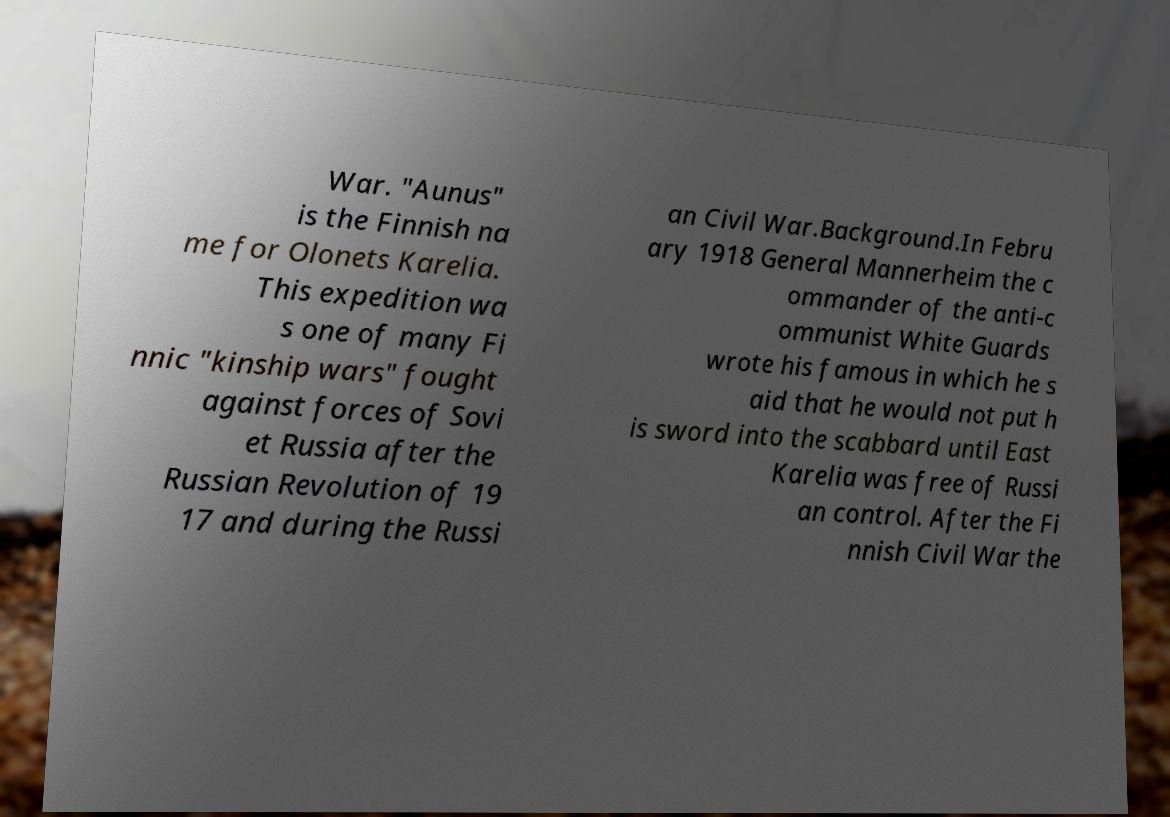Can you read and provide the text displayed in the image?This photo seems to have some interesting text. Can you extract and type it out for me? War. "Aunus" is the Finnish na me for Olonets Karelia. This expedition wa s one of many Fi nnic "kinship wars" fought against forces of Sovi et Russia after the Russian Revolution of 19 17 and during the Russi an Civil War.Background.In Febru ary 1918 General Mannerheim the c ommander of the anti-c ommunist White Guards wrote his famous in which he s aid that he would not put h is sword into the scabbard until East Karelia was free of Russi an control. After the Fi nnish Civil War the 